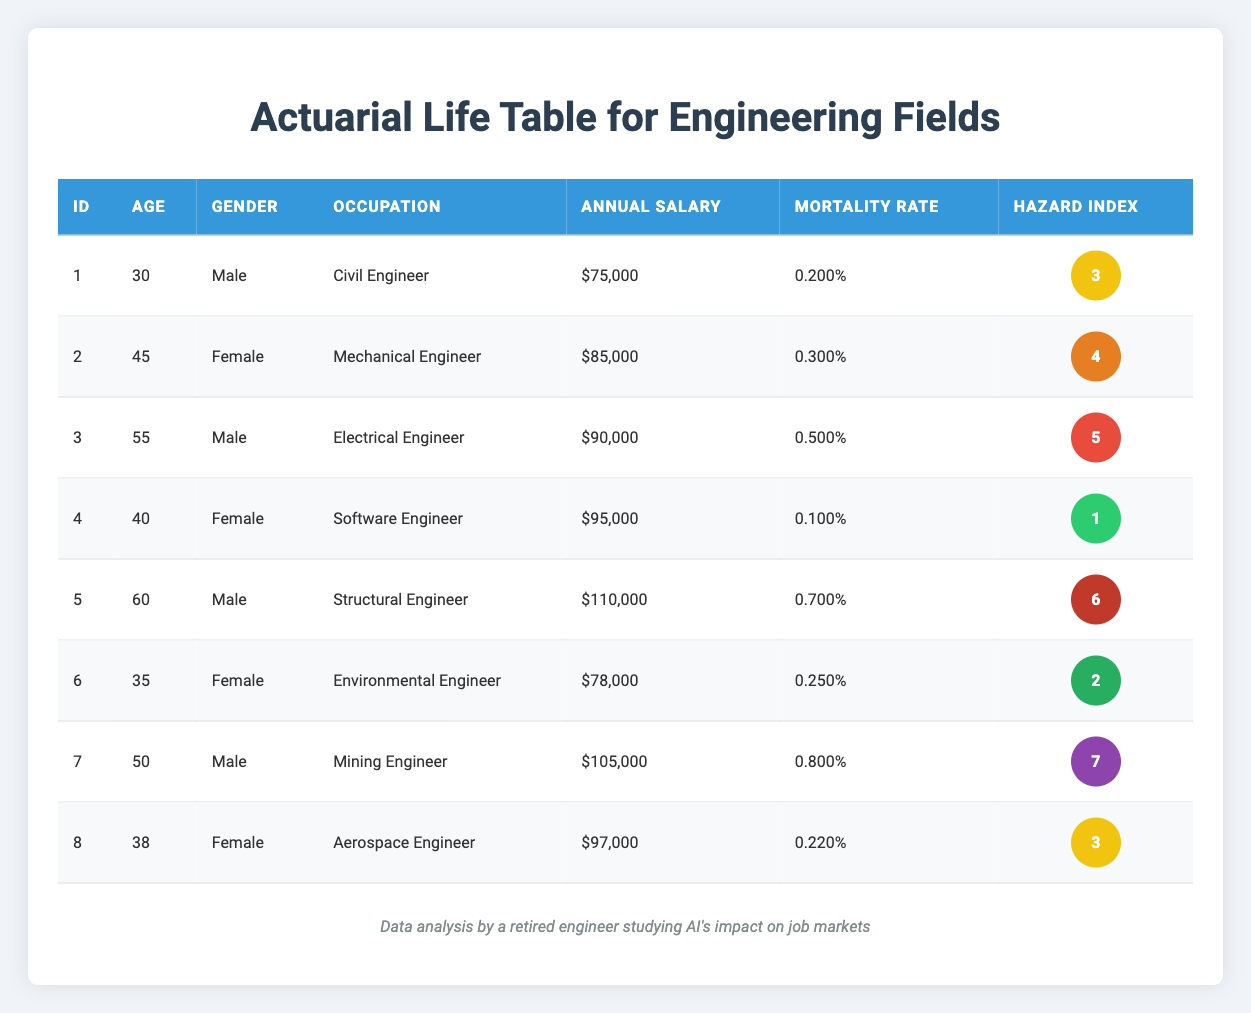What is the mortality rate of the Electrical Engineer? The mortality rate for the Electrical Engineer can be found in the table under the respective occupation. Looking at the row where the occupation is "Electrical Engineer," the mortality rate is 0.005 or 0.500%.
Answer: 0.500% How many policyholders are male? To find the number of male policyholders, I will count the rows in the table where the gender is listed as "Male." Scanning the table, there are four such entries for Civil Engineer, Electrical Engineer, Structural Engineer, and Mining Engineer.
Answer: 4 What is the average annual salary of all the policyholders? To calculate the average annual salary, I will first sum all the salaries: 75000 + 85000 + 90000 + 95000 + 110000 + 78000 + 105000 + 97000 =  798000. There are 8 policyholders, so the average salary is 798000 / 8 = 99750.
Answer: 99750 Is the hazard index for the Mining Engineer higher than that of the Electrical Engineer? By looking at the table, the hazard index for the Mining Engineer is 7 while for the Electrical Engineer it is 5. Since 7 is greater than 5, the statement is true.
Answer: Yes What is the difference in mortality rates between the Structural Engineer and the Software Engineer? To find the difference, I will subtract the mortality rate of the Software Engineer from that of the Structural Engineer. The mortality rate for the Structural Engineer is 0.007 (0.700%) and for the Software Engineer is 0.001 (0.100%). Thus, the difference is 0.007 - 0.001 = 0.006.
Answer: 0.006 What occupation has the highest hazard index and what is its mortality rate? Looking through the hazard index column, the highest value is 7, which corresponds to the Mining Engineer. The associated mortality rate for the Mining Engineer is 0.008 or 0.800%.
Answer: Mining Engineer, 0.800% What percentage of policyholders are female? There are 8 total policyholders and 4 of them are female (Mechanical Engineer, Software Engineer, Environmental Engineer, and Aerospace Engineer). To find the percentage, I calculate (4 / 8) * 100, which is 50%.
Answer: 50% Are policyholders with a hazard index of 6 more likely to have a higher salary than those with a hazard index of 1? The Structural Engineer with a hazard index of 6 has an annual salary of 110000, while the Software Engineer with a hazard index of 1 has an annual salary of 95000. Since 110000 is greater than 95000, yes, they are more likely to have a higher salary.
Answer: Yes 